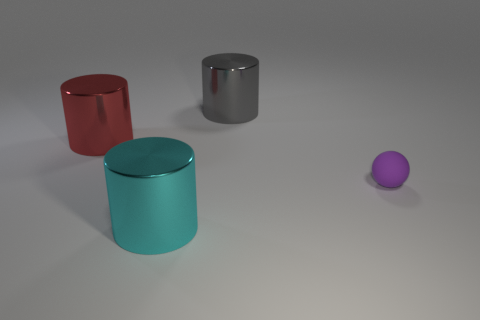Is the cyan cylinder made of the same material as the thing on the right side of the big gray thing?
Keep it short and to the point. No. Is there anything else that is made of the same material as the tiny thing?
Keep it short and to the point. No. Are there more large gray spheres than tiny purple rubber things?
Give a very brief answer. No. There is a tiny thing that is on the right side of the large object left of the large shiny thing in front of the purple rubber object; what shape is it?
Offer a very short reply. Sphere. Are the cylinder in front of the tiny matte thing and the gray thing that is on the left side of the sphere made of the same material?
Provide a succinct answer. Yes. What is the shape of the large red thing that is the same material as the cyan thing?
Keep it short and to the point. Cylinder. Is there anything else that is the same color as the tiny rubber object?
Provide a succinct answer. No. How many gray metallic things are there?
Keep it short and to the point. 1. There is a large thing that is left of the cylinder in front of the rubber thing; what is its material?
Your answer should be very brief. Metal. What is the color of the large cylinder in front of the object that is on the right side of the big shiny thing to the right of the large cyan metal cylinder?
Offer a very short reply. Cyan. 